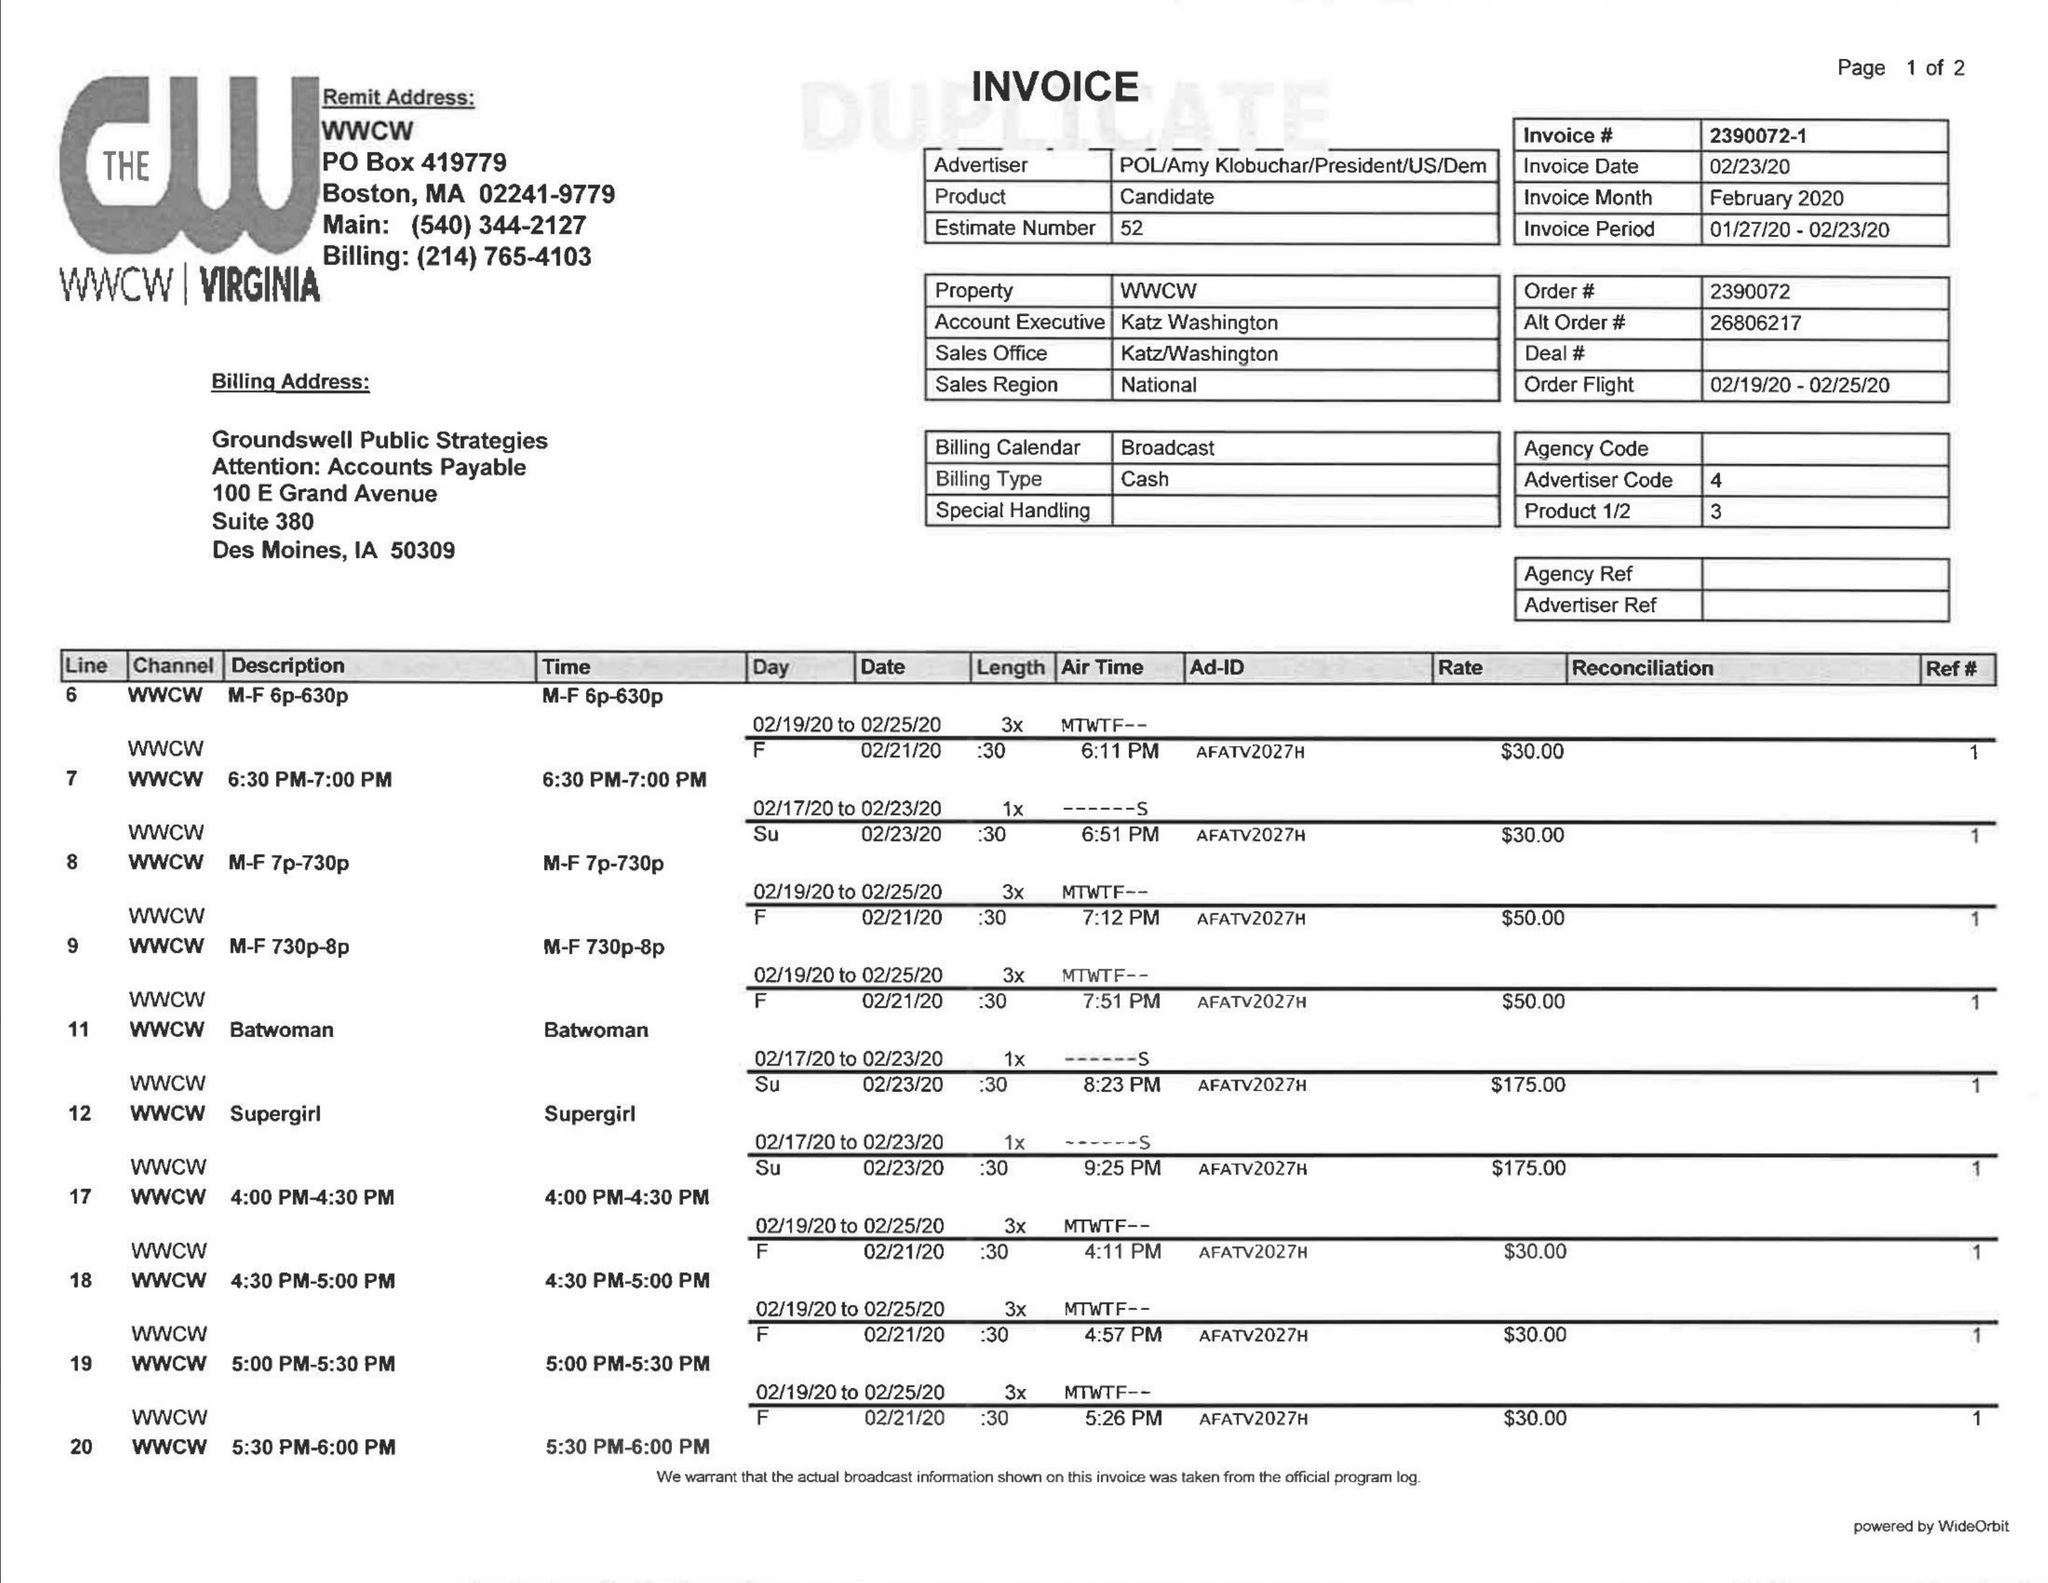What is the value for the advertiser?
Answer the question using a single word or phrase. POL/AMYKLOBUCHAR/PRESIDENT/US/DEM 